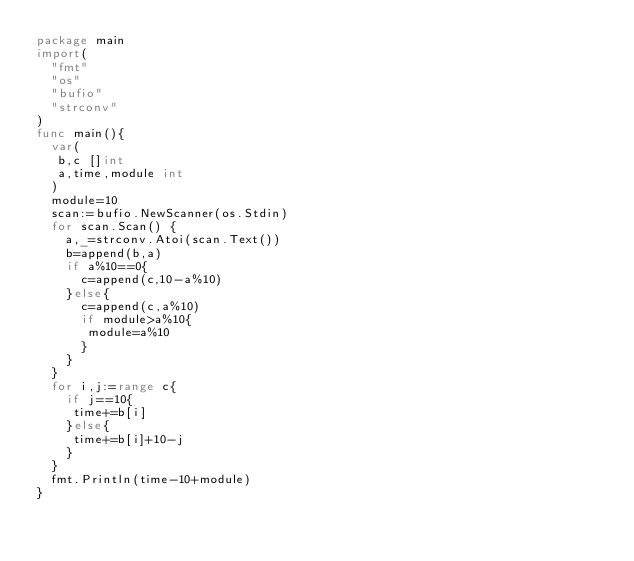<code> <loc_0><loc_0><loc_500><loc_500><_Go_>package main
import(
  "fmt"
  "os"
  "bufio"
  "strconv"
)
func main(){
  var(
   b,c []int
   a,time,module int
  )
  module=10
  scan:=bufio.NewScanner(os.Stdin)
  for scan.Scan() {
    a,_=strconv.Atoi(scan.Text())
    b=append(b,a)
    if a%10==0{
      c=append(c,10-a%10)
    }else{
      c=append(c,a%10)
      if module>a%10{
       module=a%10 
      }
    }
  }
  for i,j:=range c{
    if j==10{
     time+=b[i]
    }else{
     time+=b[i]+10-j 
    }
  }
  fmt.Println(time-10+module)
}</code> 